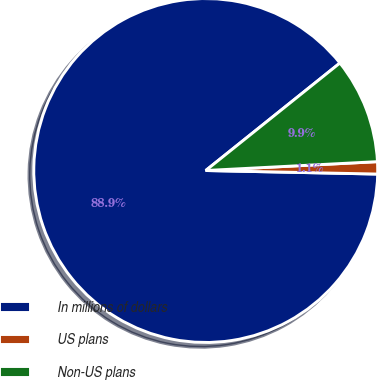<chart> <loc_0><loc_0><loc_500><loc_500><pie_chart><fcel>In millions of dollars<fcel>US plans<fcel>Non-US plans<nl><fcel>88.93%<fcel>1.15%<fcel>9.93%<nl></chart> 